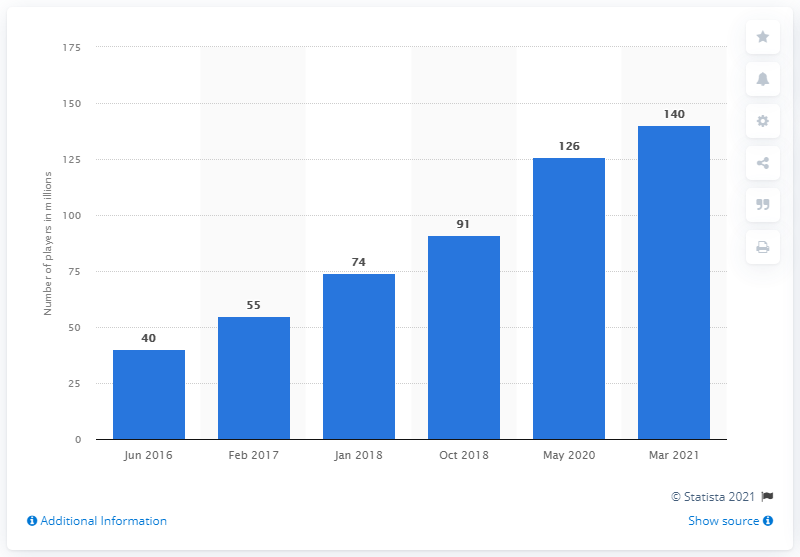Identify some key points in this picture. Since its release in 2011, Minecraft has been played by over 140 million people worldwide. 